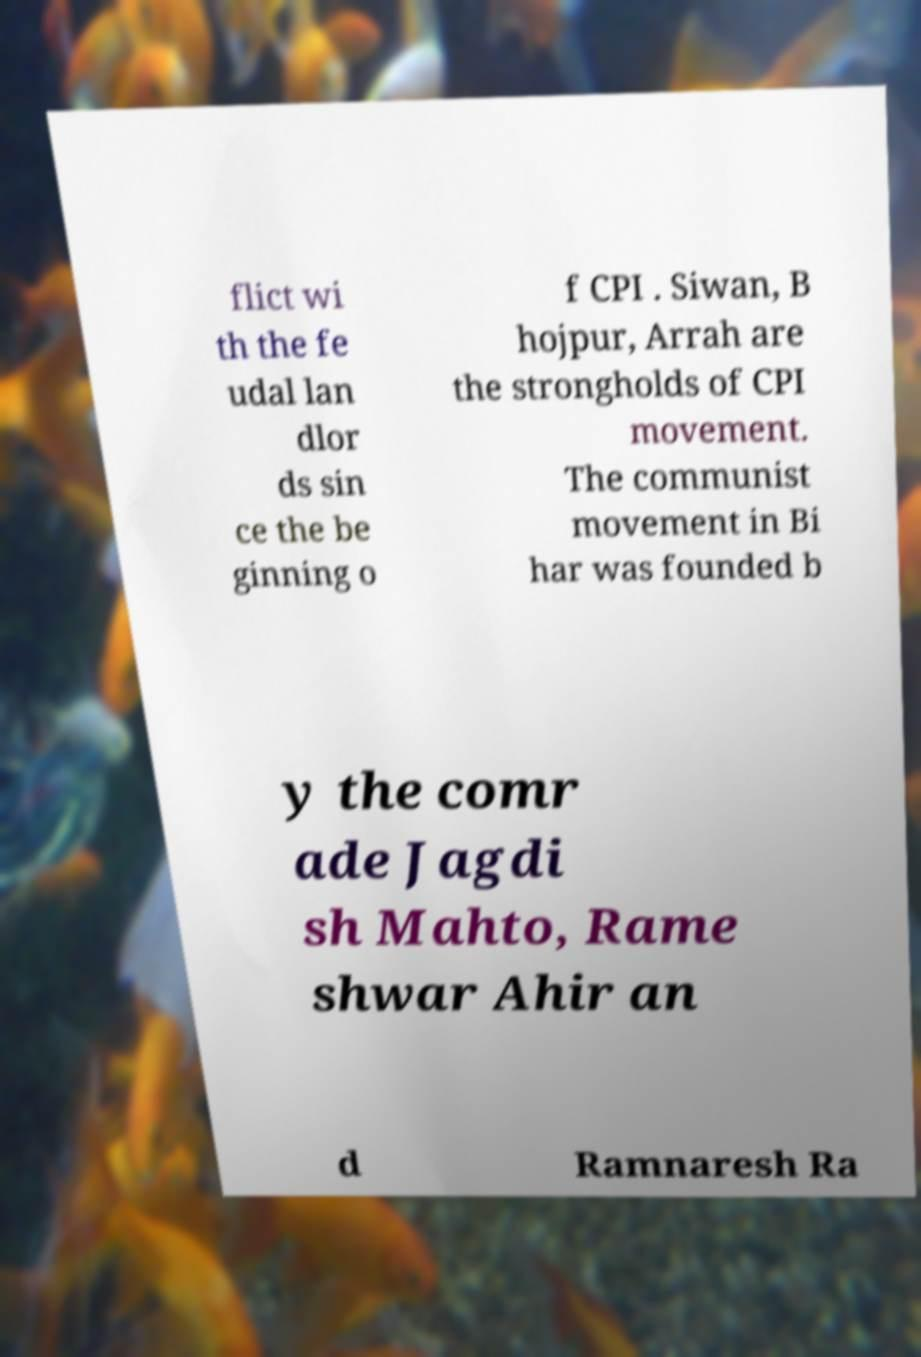I need the written content from this picture converted into text. Can you do that? flict wi th the fe udal lan dlor ds sin ce the be ginning o f CPI . Siwan, B hojpur, Arrah are the strongholds of CPI movement. The communist movement in Bi har was founded b y the comr ade Jagdi sh Mahto, Rame shwar Ahir an d Ramnaresh Ra 